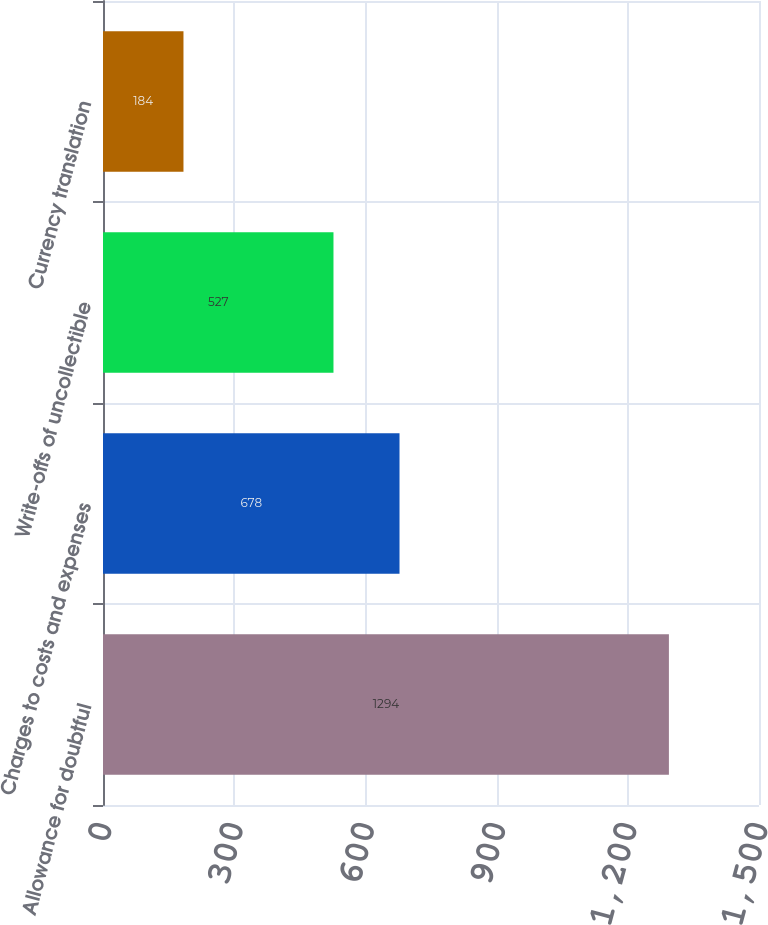Convert chart to OTSL. <chart><loc_0><loc_0><loc_500><loc_500><bar_chart><fcel>Allowance for doubtful<fcel>Charges to costs and expenses<fcel>Write-offs of uncollectible<fcel>Currency translation<nl><fcel>1294<fcel>678<fcel>527<fcel>184<nl></chart> 